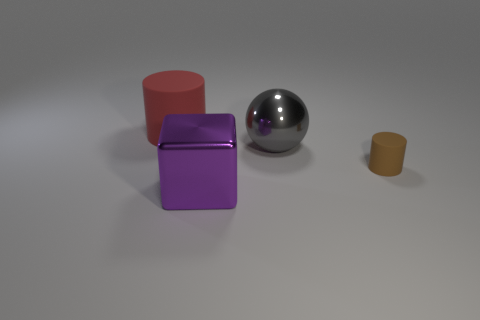There is a purple metallic object in front of the big matte cylinder; is its shape the same as the gray thing?
Provide a succinct answer. No. Are there fewer gray metal spheres left of the large red thing than small purple blocks?
Ensure brevity in your answer.  No. Is there a large purple cube that has the same material as the big gray object?
Provide a succinct answer. Yes. There is a cylinder that is the same size as the purple metallic block; what is it made of?
Provide a succinct answer. Rubber. Is the number of large red cylinders to the right of the brown object less than the number of matte cylinders that are left of the large purple block?
Keep it short and to the point. Yes. The large thing that is both in front of the big rubber thing and behind the large metal block has what shape?
Offer a terse response. Sphere. How many yellow things are the same shape as the big red rubber thing?
Your answer should be very brief. 0. What size is the other red cylinder that is the same material as the small cylinder?
Your answer should be compact. Large. Are there more purple objects than red cubes?
Give a very brief answer. Yes. There is a object on the left side of the big metallic cube; what is its color?
Ensure brevity in your answer.  Red. 